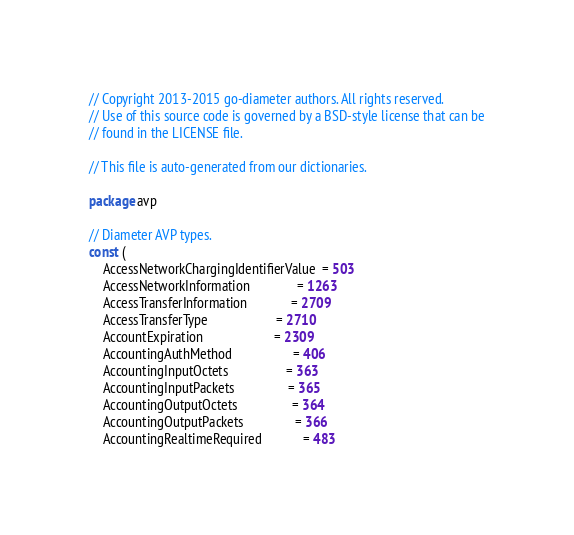Convert code to text. <code><loc_0><loc_0><loc_500><loc_500><_Go_>// Copyright 2013-2015 go-diameter authors. All rights reserved.
// Use of this source code is governed by a BSD-style license that can be
// found in the LICENSE file.

// This file is auto-generated from our dictionaries.

package avp

// Diameter AVP types.
const (
	AccessNetworkChargingIdentifierValue  = 503
	AccessNetworkInformation              = 1263
	AccessTransferInformation             = 2709
	AccessTransferType                    = 2710
	AccountExpiration                     = 2309
	AccountingAuthMethod                  = 406
	AccountingInputOctets                 = 363
	AccountingInputPackets                = 365
	AccountingOutputOctets                = 364
	AccountingOutputPackets               = 366
	AccountingRealtimeRequired            = 483</code> 